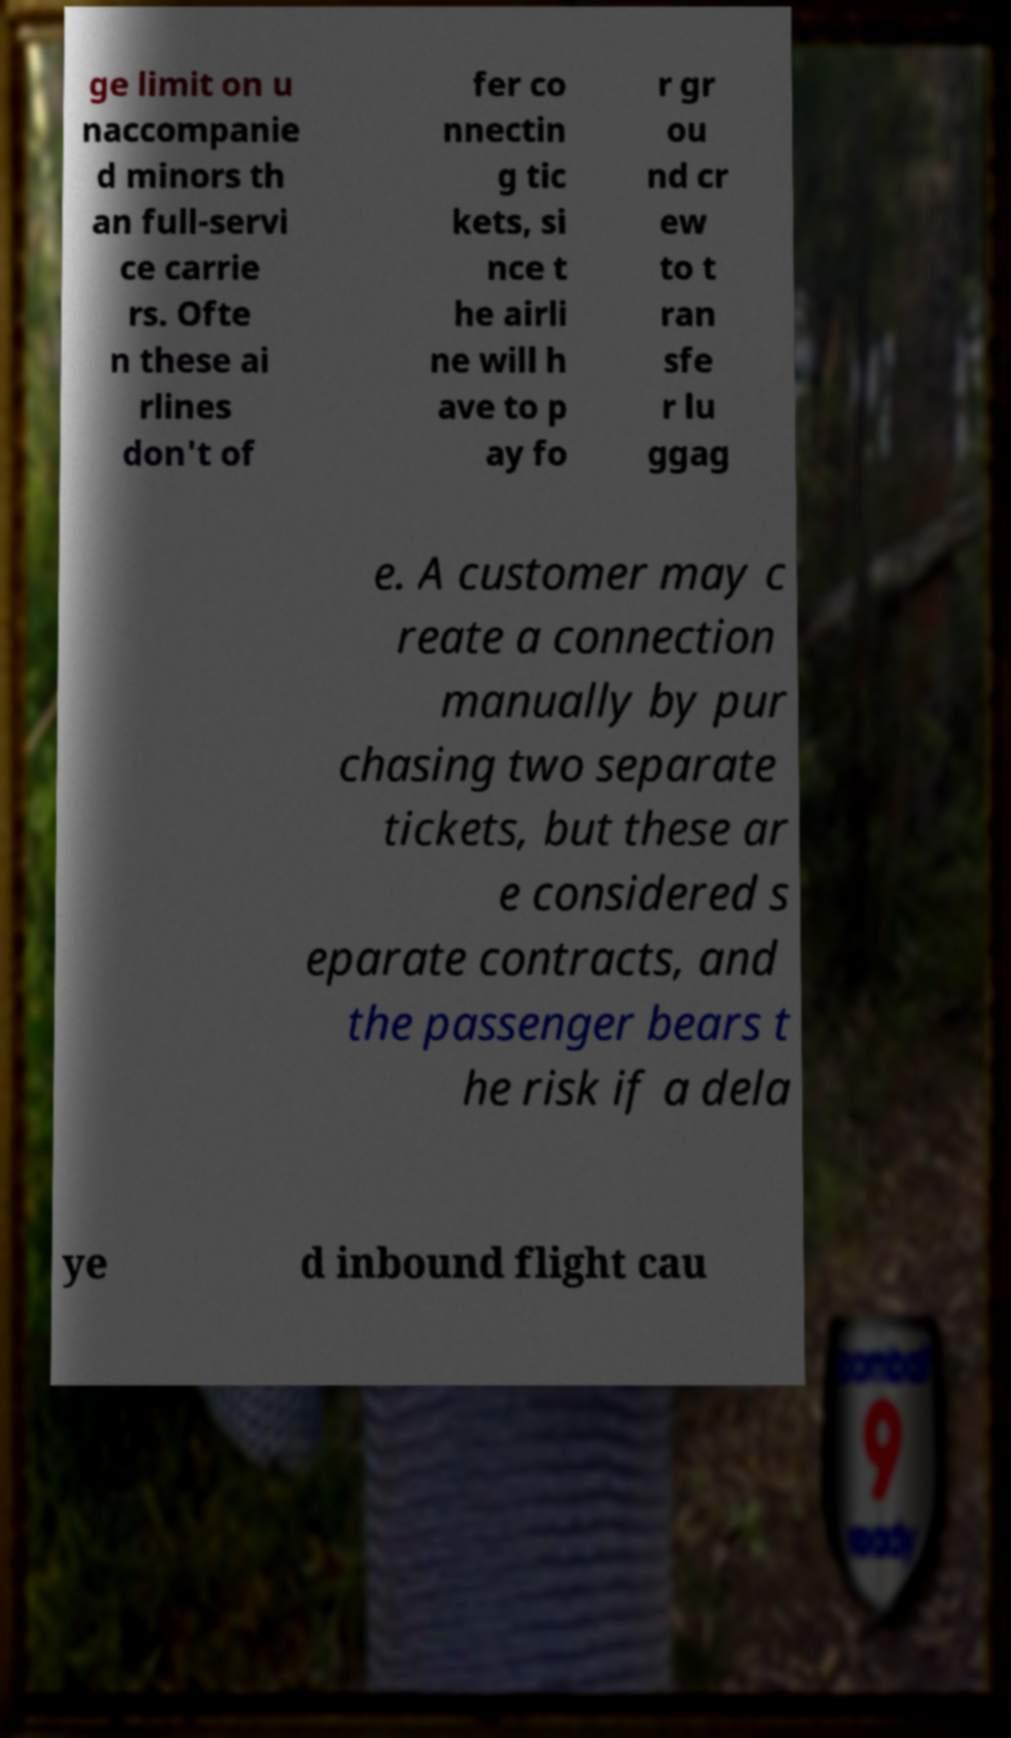Could you assist in decoding the text presented in this image and type it out clearly? ge limit on u naccompanie d minors th an full-servi ce carrie rs. Ofte n these ai rlines don't of fer co nnectin g tic kets, si nce t he airli ne will h ave to p ay fo r gr ou nd cr ew to t ran sfe r lu ggag e. A customer may c reate a connection manually by pur chasing two separate tickets, but these ar e considered s eparate contracts, and the passenger bears t he risk if a dela ye d inbound flight cau 